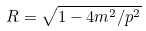<formula> <loc_0><loc_0><loc_500><loc_500>R = \sqrt { 1 - 4 m ^ { 2 } / p ^ { 2 } }</formula> 